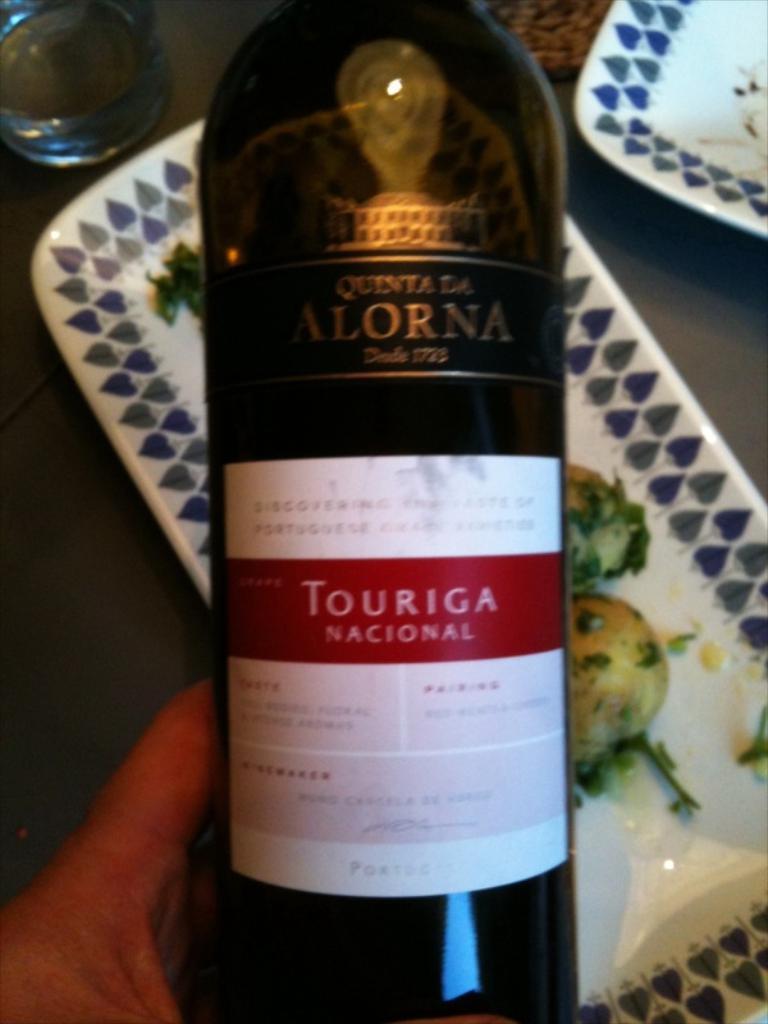Whats the name of the wine?
Offer a terse response. Touriga. 